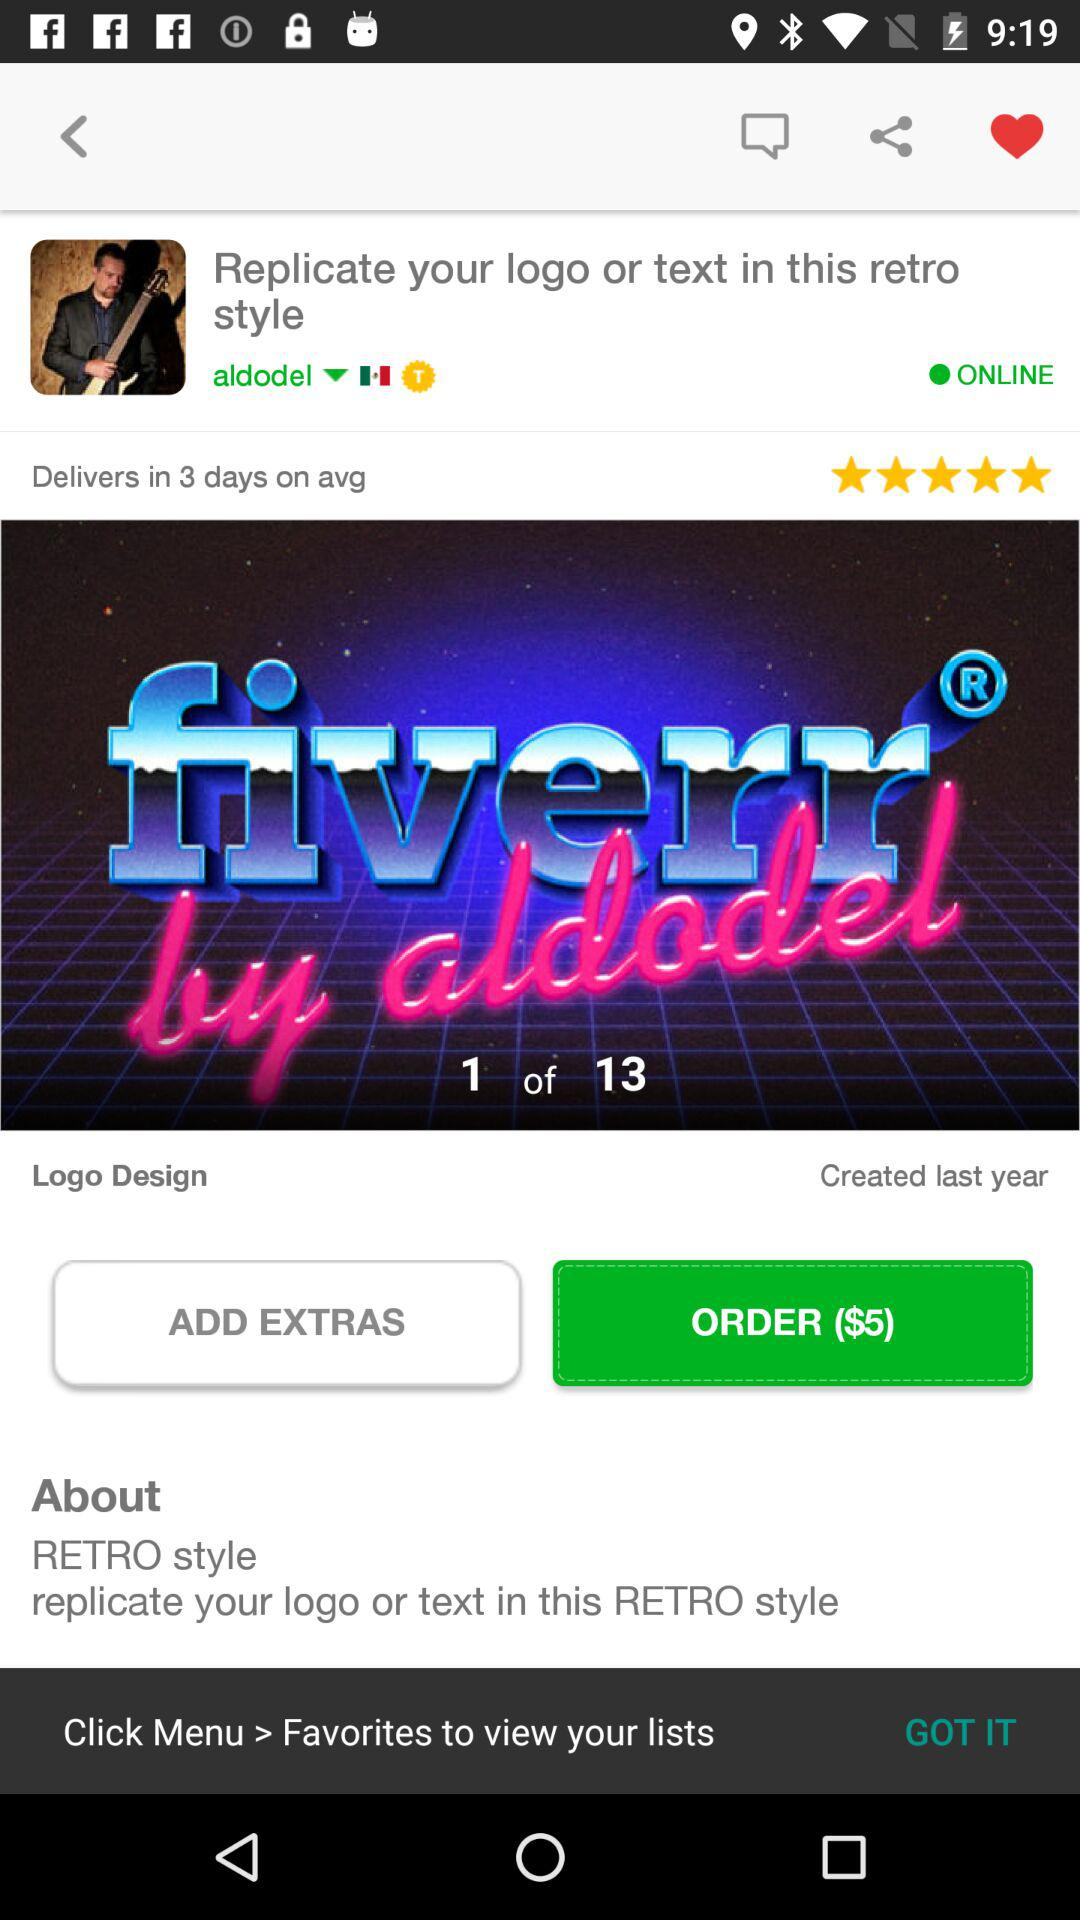What is the status of Aldodel? The status of Aldodel is "ONLINE". 